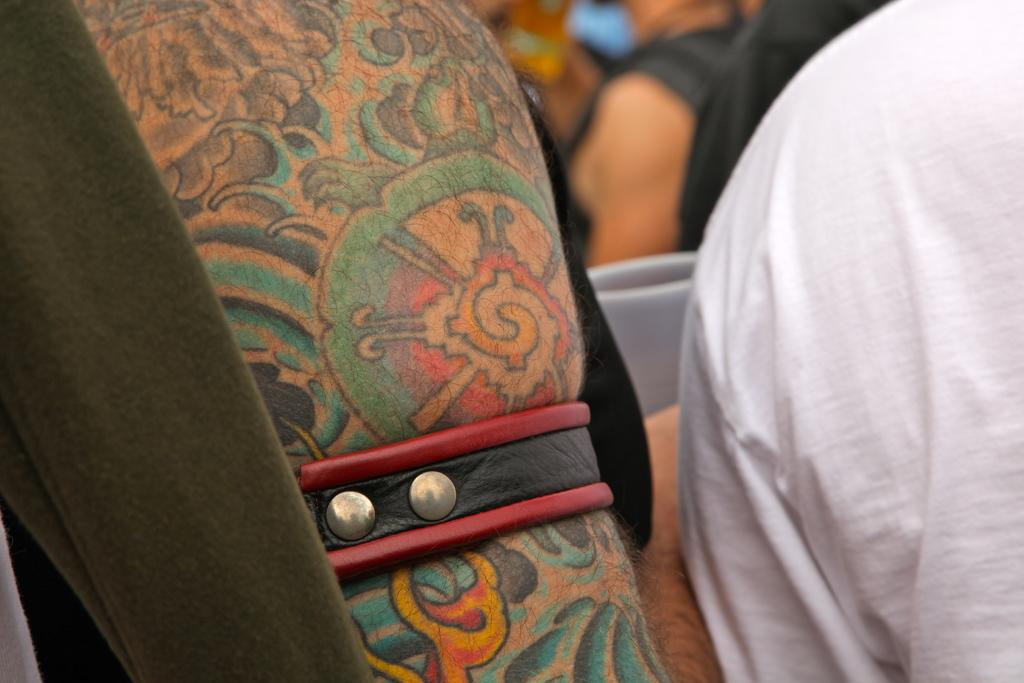How many people are in the image? There is a group of people in the image. Can you describe the background of the image? The background of the image is blurry. What news is the writer sharing with the toad in the image? There is no writer or toad present in the image. 